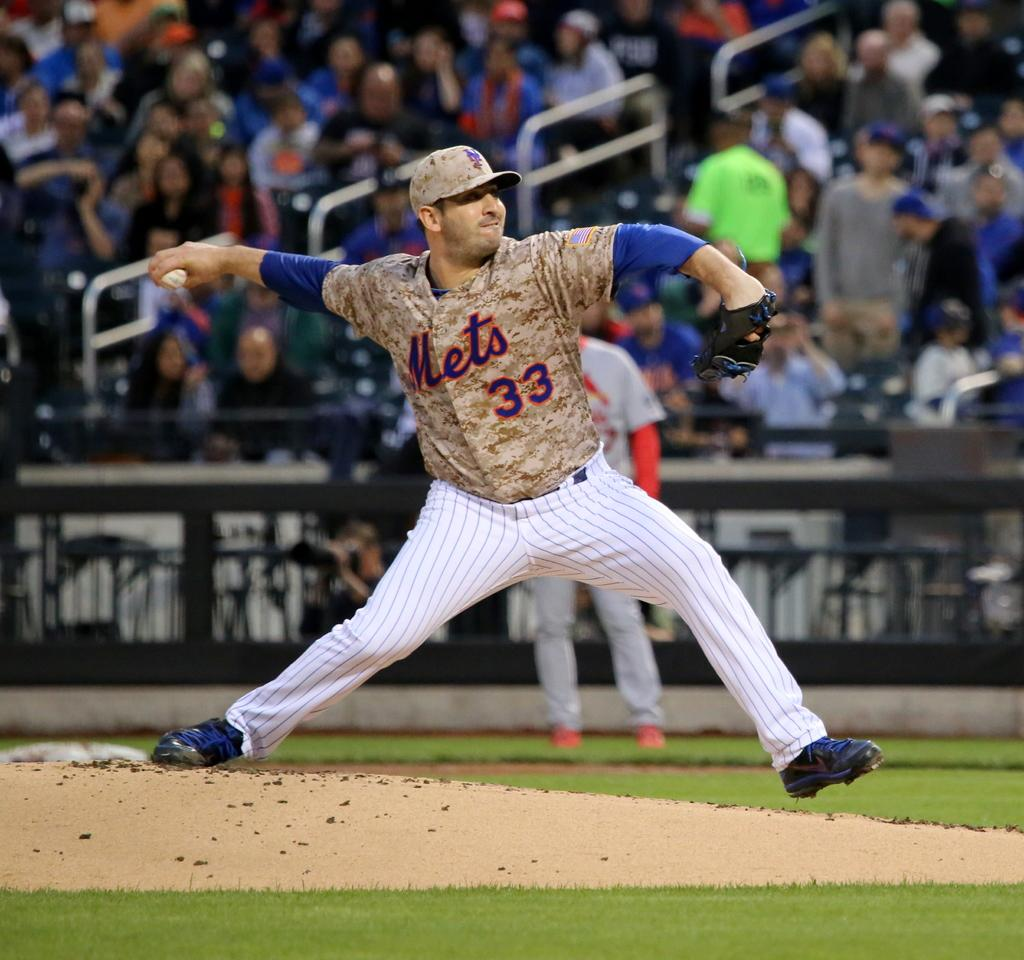<image>
Share a concise interpretation of the image provided. Baseball player for the Mets about to pitch the ball. 